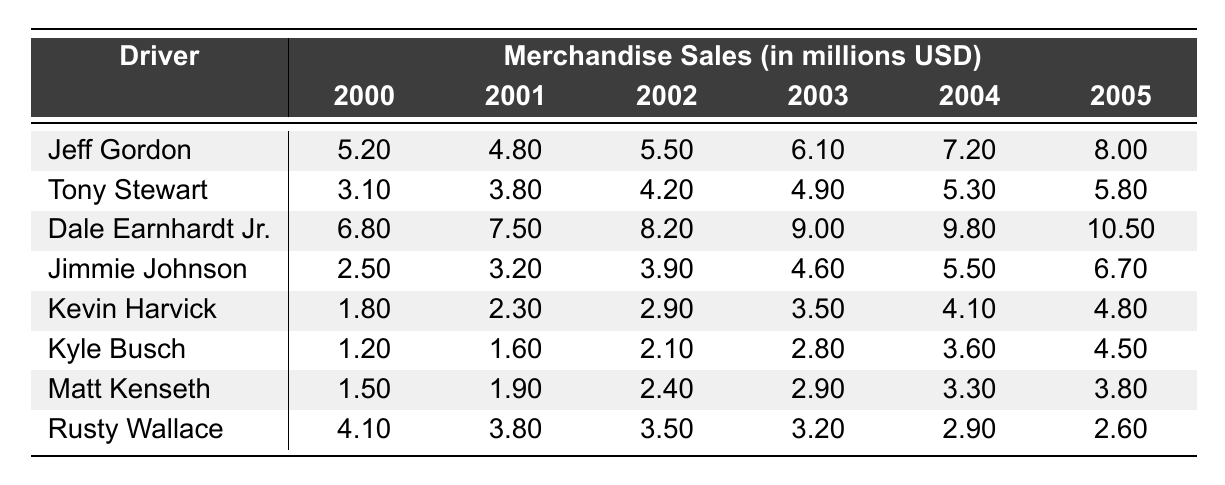What was the highest merchandise sales figure for Dale Earnhardt Jr. between 2000 and 2005? The highest sales figure for Dale Earnhardt Jr. is from 2005, which was 10.5 million.
Answer: 10.5 million Which driver had the lowest merchandise sales in 2000? In 2000, the driver with the lowest merchandise sales was Kevin Harvick, with sales of 1.8 million.
Answer: Kevin Harvick What is the total merchandise sales for Jeff Gordon from 2000 to 2005? Summing Jeff Gordon's sales figures (5.2 + 4.8 + 5.5 + 6.1 + 7.2 + 8.0) gives us a total of 36.8 million.
Answer: 36.8 million Did Kevin Harvick's merchandise sales increase every year from 2000 to 2005? No, Kevin Harvick's sales increased in the first four years but remained the same in 2005 compared to the previous year.
Answer: No What was the average merchandise sales for Jimmie Johnson from 2000 to 2005? Calculating the average: (2.5 + 3.2 + 3.9 + 4.6 + 5.5 + 6.7) = 26.4; dividing by 6 gives an average of 4.4 million.
Answer: 4.4 million Which driver had a consistent decrease in merchandise sales from 2000 to 2005? Rusty Wallace experienced a decline in sales year over year, starting from 4.1 million in 2000 to 2.6 million in 2005.
Answer: Rusty Wallace What was the difference in merchandise sales between Tony Stewart in 2002 and Dale Earnhardt Jr. in 2005? Tony Stewart's sales in 2002 were 4.2 million, while Dale Earnhardt Jr.'s in 2005 were 10.5 million, resulting in a difference of 6.3 million.
Answer: 6.3 million Which driver had the highest merchandise sales in 2004? In 2004, Dale Earnhardt Jr. had the highest merchandise sales at 9.8 million.
Answer: Dale Earnhardt Jr What was the percentage increase in merchandise sales for Kyle Busch from 2000 to 2005? Kyle Busch's sales increased from 1.2 million in 2000 to 4.5 million in 2005. The percentage increase is ((4.5 - 1.2) / 1.2) * 100, which is 275%.
Answer: 275% 